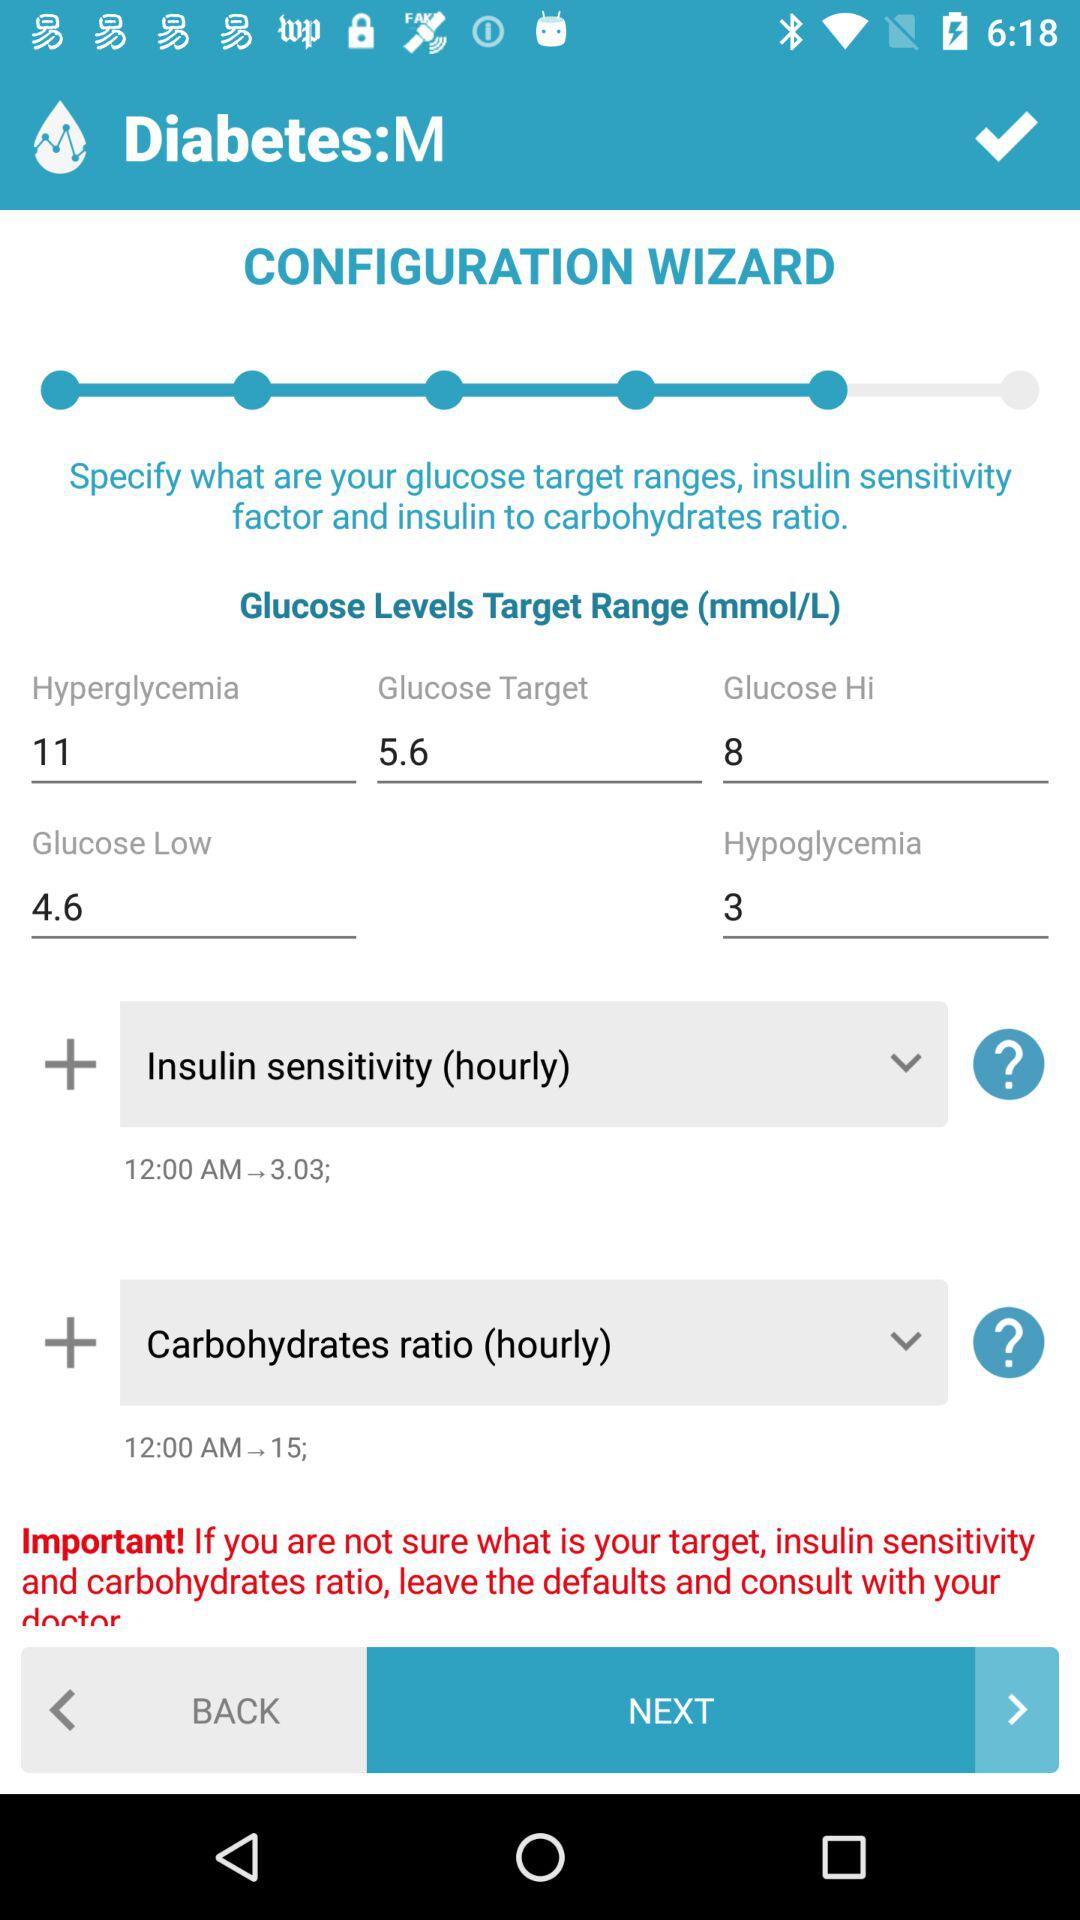What is the insulin sensitivity factor at 12:00 AM? The insulin sensitivity factor at 12:00 AM is 3.03. 